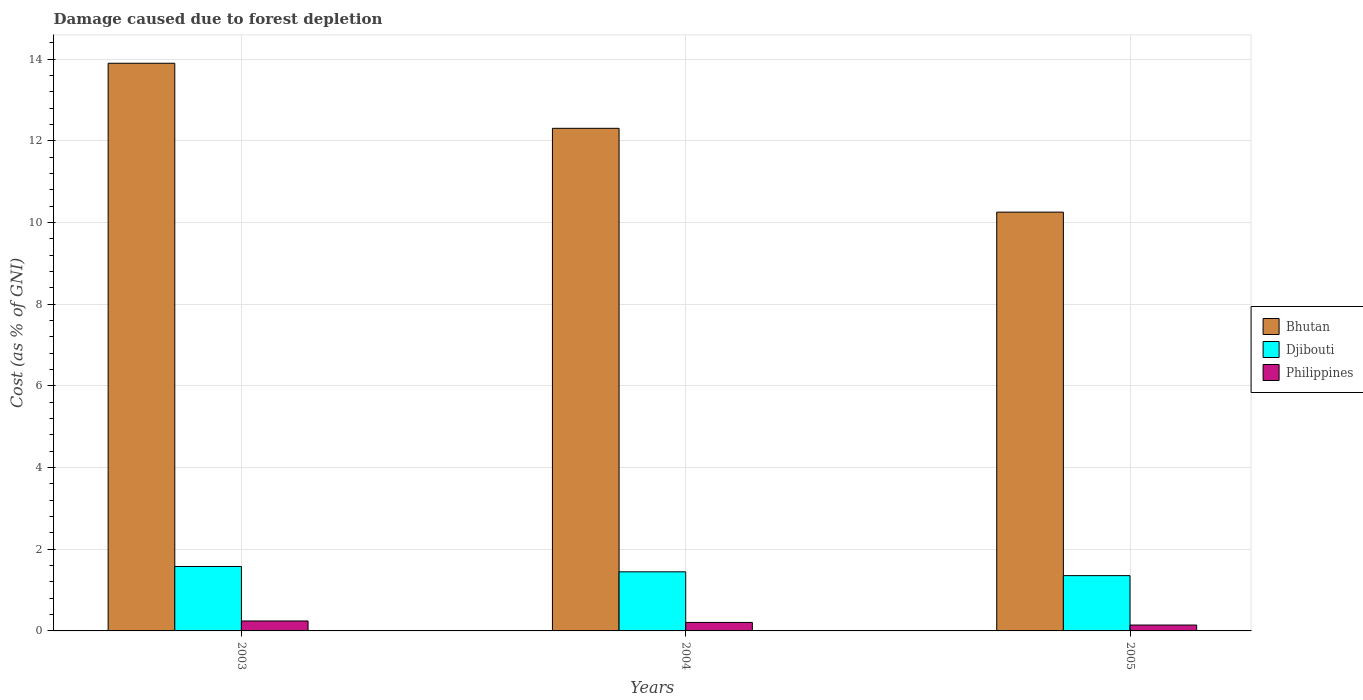How many different coloured bars are there?
Offer a terse response. 3. How many bars are there on the 3rd tick from the right?
Your answer should be compact. 3. What is the label of the 2nd group of bars from the left?
Offer a very short reply. 2004. What is the cost of damage caused due to forest depletion in Philippines in 2003?
Give a very brief answer. 0.24. Across all years, what is the maximum cost of damage caused due to forest depletion in Djibouti?
Offer a very short reply. 1.58. Across all years, what is the minimum cost of damage caused due to forest depletion in Djibouti?
Provide a short and direct response. 1.35. In which year was the cost of damage caused due to forest depletion in Philippines minimum?
Make the answer very short. 2005. What is the total cost of damage caused due to forest depletion in Philippines in the graph?
Make the answer very short. 0.6. What is the difference between the cost of damage caused due to forest depletion in Philippines in 2004 and that in 2005?
Offer a terse response. 0.06. What is the difference between the cost of damage caused due to forest depletion in Bhutan in 2005 and the cost of damage caused due to forest depletion in Djibouti in 2004?
Your answer should be compact. 8.81. What is the average cost of damage caused due to forest depletion in Philippines per year?
Make the answer very short. 0.2. In the year 2004, what is the difference between the cost of damage caused due to forest depletion in Bhutan and cost of damage caused due to forest depletion in Djibouti?
Your response must be concise. 10.86. In how many years, is the cost of damage caused due to forest depletion in Djibouti greater than 5.2 %?
Your response must be concise. 0. What is the ratio of the cost of damage caused due to forest depletion in Djibouti in 2004 to that in 2005?
Ensure brevity in your answer.  1.07. Is the difference between the cost of damage caused due to forest depletion in Bhutan in 2003 and 2005 greater than the difference between the cost of damage caused due to forest depletion in Djibouti in 2003 and 2005?
Keep it short and to the point. Yes. What is the difference between the highest and the second highest cost of damage caused due to forest depletion in Philippines?
Give a very brief answer. 0.04. What is the difference between the highest and the lowest cost of damage caused due to forest depletion in Bhutan?
Make the answer very short. 3.65. In how many years, is the cost of damage caused due to forest depletion in Djibouti greater than the average cost of damage caused due to forest depletion in Djibouti taken over all years?
Ensure brevity in your answer.  1. Is the sum of the cost of damage caused due to forest depletion in Bhutan in 2003 and 2004 greater than the maximum cost of damage caused due to forest depletion in Djibouti across all years?
Offer a terse response. Yes. What does the 3rd bar from the left in 2004 represents?
Your answer should be compact. Philippines. Is it the case that in every year, the sum of the cost of damage caused due to forest depletion in Philippines and cost of damage caused due to forest depletion in Djibouti is greater than the cost of damage caused due to forest depletion in Bhutan?
Your response must be concise. No. What is the difference between two consecutive major ticks on the Y-axis?
Ensure brevity in your answer.  2. Are the values on the major ticks of Y-axis written in scientific E-notation?
Ensure brevity in your answer.  No. Does the graph contain grids?
Offer a very short reply. Yes. How are the legend labels stacked?
Give a very brief answer. Vertical. What is the title of the graph?
Offer a terse response. Damage caused due to forest depletion. What is the label or title of the X-axis?
Your answer should be compact. Years. What is the label or title of the Y-axis?
Provide a short and direct response. Cost (as % of GNI). What is the Cost (as % of GNI) in Bhutan in 2003?
Your answer should be very brief. 13.9. What is the Cost (as % of GNI) of Djibouti in 2003?
Provide a succinct answer. 1.58. What is the Cost (as % of GNI) of Philippines in 2003?
Your answer should be compact. 0.24. What is the Cost (as % of GNI) of Bhutan in 2004?
Ensure brevity in your answer.  12.31. What is the Cost (as % of GNI) of Djibouti in 2004?
Provide a short and direct response. 1.45. What is the Cost (as % of GNI) in Philippines in 2004?
Your response must be concise. 0.21. What is the Cost (as % of GNI) of Bhutan in 2005?
Give a very brief answer. 10.26. What is the Cost (as % of GNI) in Djibouti in 2005?
Your answer should be very brief. 1.35. What is the Cost (as % of GNI) in Philippines in 2005?
Offer a terse response. 0.14. Across all years, what is the maximum Cost (as % of GNI) of Bhutan?
Provide a succinct answer. 13.9. Across all years, what is the maximum Cost (as % of GNI) of Djibouti?
Offer a very short reply. 1.58. Across all years, what is the maximum Cost (as % of GNI) in Philippines?
Your response must be concise. 0.24. Across all years, what is the minimum Cost (as % of GNI) in Bhutan?
Provide a short and direct response. 10.26. Across all years, what is the minimum Cost (as % of GNI) of Djibouti?
Make the answer very short. 1.35. Across all years, what is the minimum Cost (as % of GNI) of Philippines?
Your answer should be very brief. 0.14. What is the total Cost (as % of GNI) of Bhutan in the graph?
Keep it short and to the point. 36.47. What is the total Cost (as % of GNI) of Djibouti in the graph?
Your response must be concise. 4.38. What is the total Cost (as % of GNI) in Philippines in the graph?
Provide a succinct answer. 0.6. What is the difference between the Cost (as % of GNI) in Bhutan in 2003 and that in 2004?
Offer a very short reply. 1.59. What is the difference between the Cost (as % of GNI) in Djibouti in 2003 and that in 2004?
Give a very brief answer. 0.13. What is the difference between the Cost (as % of GNI) in Philippines in 2003 and that in 2004?
Give a very brief answer. 0.04. What is the difference between the Cost (as % of GNI) of Bhutan in 2003 and that in 2005?
Keep it short and to the point. 3.65. What is the difference between the Cost (as % of GNI) in Djibouti in 2003 and that in 2005?
Provide a succinct answer. 0.22. What is the difference between the Cost (as % of GNI) in Philippines in 2003 and that in 2005?
Provide a short and direct response. 0.1. What is the difference between the Cost (as % of GNI) of Bhutan in 2004 and that in 2005?
Provide a short and direct response. 2.05. What is the difference between the Cost (as % of GNI) in Djibouti in 2004 and that in 2005?
Offer a very short reply. 0.09. What is the difference between the Cost (as % of GNI) in Philippines in 2004 and that in 2005?
Offer a terse response. 0.06. What is the difference between the Cost (as % of GNI) of Bhutan in 2003 and the Cost (as % of GNI) of Djibouti in 2004?
Give a very brief answer. 12.45. What is the difference between the Cost (as % of GNI) of Bhutan in 2003 and the Cost (as % of GNI) of Philippines in 2004?
Your response must be concise. 13.69. What is the difference between the Cost (as % of GNI) of Djibouti in 2003 and the Cost (as % of GNI) of Philippines in 2004?
Your answer should be very brief. 1.37. What is the difference between the Cost (as % of GNI) in Bhutan in 2003 and the Cost (as % of GNI) in Djibouti in 2005?
Your answer should be very brief. 12.55. What is the difference between the Cost (as % of GNI) in Bhutan in 2003 and the Cost (as % of GNI) in Philippines in 2005?
Offer a very short reply. 13.76. What is the difference between the Cost (as % of GNI) of Djibouti in 2003 and the Cost (as % of GNI) of Philippines in 2005?
Give a very brief answer. 1.43. What is the difference between the Cost (as % of GNI) of Bhutan in 2004 and the Cost (as % of GNI) of Djibouti in 2005?
Your response must be concise. 10.95. What is the difference between the Cost (as % of GNI) in Bhutan in 2004 and the Cost (as % of GNI) in Philippines in 2005?
Your answer should be compact. 12.16. What is the difference between the Cost (as % of GNI) of Djibouti in 2004 and the Cost (as % of GNI) of Philippines in 2005?
Your response must be concise. 1.3. What is the average Cost (as % of GNI) in Bhutan per year?
Provide a short and direct response. 12.16. What is the average Cost (as % of GNI) in Djibouti per year?
Make the answer very short. 1.46. What is the average Cost (as % of GNI) of Philippines per year?
Your answer should be very brief. 0.2. In the year 2003, what is the difference between the Cost (as % of GNI) of Bhutan and Cost (as % of GNI) of Djibouti?
Your answer should be very brief. 12.32. In the year 2003, what is the difference between the Cost (as % of GNI) of Bhutan and Cost (as % of GNI) of Philippines?
Offer a terse response. 13.66. In the year 2003, what is the difference between the Cost (as % of GNI) in Djibouti and Cost (as % of GNI) in Philippines?
Provide a short and direct response. 1.33. In the year 2004, what is the difference between the Cost (as % of GNI) of Bhutan and Cost (as % of GNI) of Djibouti?
Give a very brief answer. 10.86. In the year 2004, what is the difference between the Cost (as % of GNI) of Bhutan and Cost (as % of GNI) of Philippines?
Your response must be concise. 12.1. In the year 2004, what is the difference between the Cost (as % of GNI) in Djibouti and Cost (as % of GNI) in Philippines?
Offer a terse response. 1.24. In the year 2005, what is the difference between the Cost (as % of GNI) in Bhutan and Cost (as % of GNI) in Djibouti?
Ensure brevity in your answer.  8.9. In the year 2005, what is the difference between the Cost (as % of GNI) in Bhutan and Cost (as % of GNI) in Philippines?
Offer a terse response. 10.11. In the year 2005, what is the difference between the Cost (as % of GNI) in Djibouti and Cost (as % of GNI) in Philippines?
Offer a very short reply. 1.21. What is the ratio of the Cost (as % of GNI) of Bhutan in 2003 to that in 2004?
Your response must be concise. 1.13. What is the ratio of the Cost (as % of GNI) of Djibouti in 2003 to that in 2004?
Make the answer very short. 1.09. What is the ratio of the Cost (as % of GNI) in Philippines in 2003 to that in 2004?
Make the answer very short. 1.17. What is the ratio of the Cost (as % of GNI) of Bhutan in 2003 to that in 2005?
Give a very brief answer. 1.36. What is the ratio of the Cost (as % of GNI) of Djibouti in 2003 to that in 2005?
Give a very brief answer. 1.17. What is the ratio of the Cost (as % of GNI) in Philippines in 2003 to that in 2005?
Your response must be concise. 1.69. What is the ratio of the Cost (as % of GNI) of Bhutan in 2004 to that in 2005?
Ensure brevity in your answer.  1.2. What is the ratio of the Cost (as % of GNI) in Djibouti in 2004 to that in 2005?
Give a very brief answer. 1.07. What is the ratio of the Cost (as % of GNI) of Philippines in 2004 to that in 2005?
Your answer should be compact. 1.44. What is the difference between the highest and the second highest Cost (as % of GNI) in Bhutan?
Your answer should be very brief. 1.59. What is the difference between the highest and the second highest Cost (as % of GNI) of Djibouti?
Provide a succinct answer. 0.13. What is the difference between the highest and the second highest Cost (as % of GNI) of Philippines?
Give a very brief answer. 0.04. What is the difference between the highest and the lowest Cost (as % of GNI) in Bhutan?
Offer a very short reply. 3.65. What is the difference between the highest and the lowest Cost (as % of GNI) in Djibouti?
Provide a short and direct response. 0.22. What is the difference between the highest and the lowest Cost (as % of GNI) in Philippines?
Make the answer very short. 0.1. 